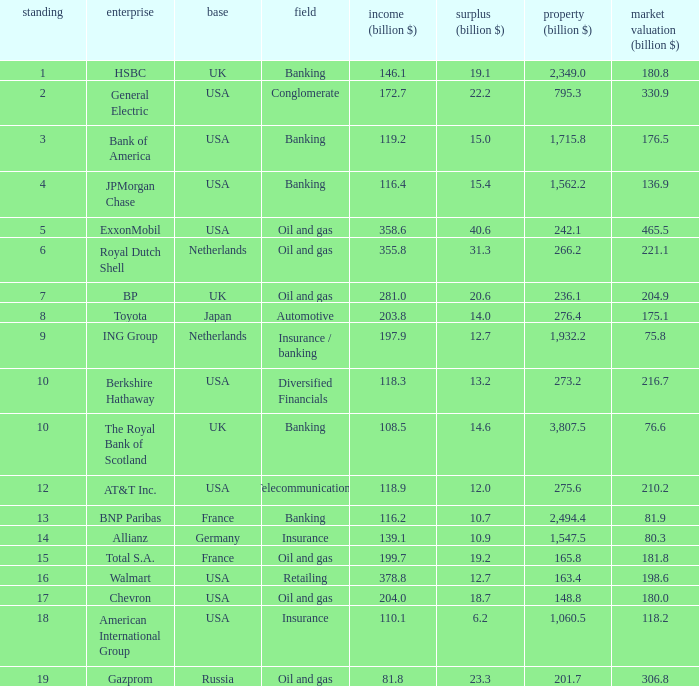What is the amount of profits in billions for companies with a market value of 204.9 billion?  20.6. 